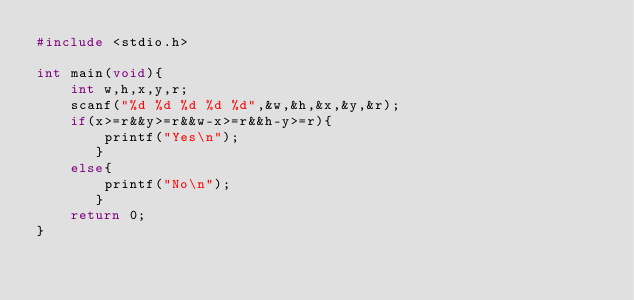Convert code to text. <code><loc_0><loc_0><loc_500><loc_500><_C_>#include <stdio.h>
          
int main(void){
    int w,h,x,y,r;
    scanf("%d %d %d %d %d",&w,&h,&x,&y,&r);
    if(x>=r&&y>=r&&w-x>=r&&h-y>=r){
        printf("Yes\n");
       }
    else{
        printf("No\n");
       }
    return 0;
}</code> 